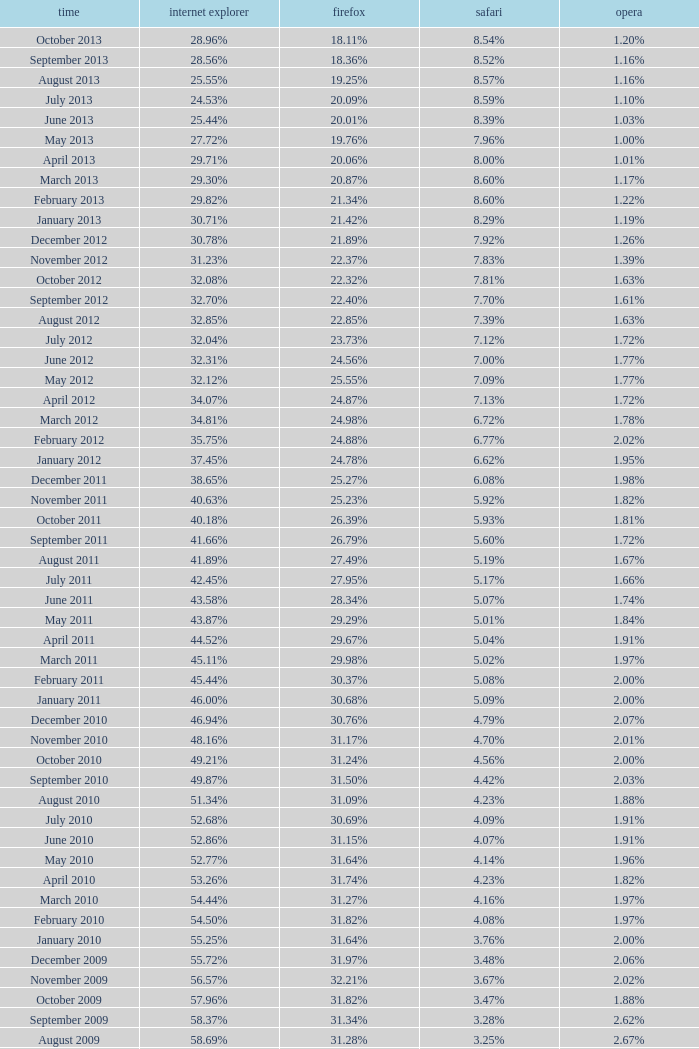What percentage of browsers were using Opera in November 2009? 2.02%. 